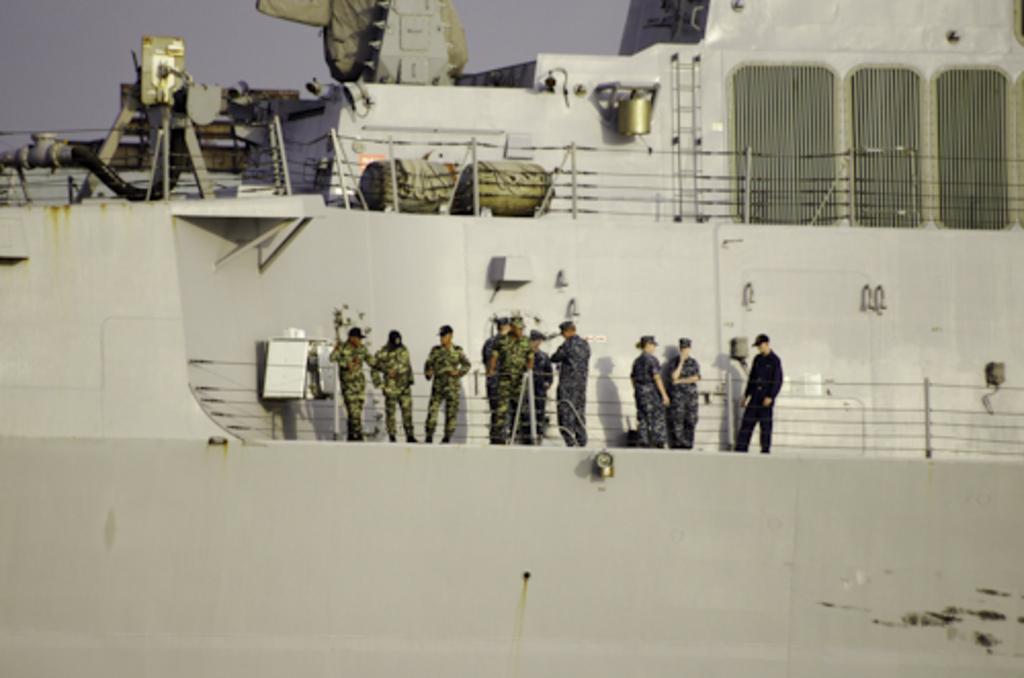How would you summarize this image in a sentence or two? In the image there is a grey ship. In the middle of the ship there are few people standing. Above the ship there are railing, pipes and few other items in it. 